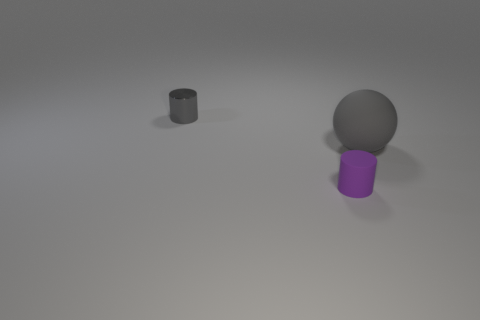What is the shape of the tiny thing that is in front of the big gray matte object?
Your answer should be compact. Cylinder. What number of other objects are there of the same material as the ball?
Offer a very short reply. 1. Is the sphere the same color as the small metallic cylinder?
Your answer should be very brief. Yes. Are there fewer gray rubber balls behind the metallic object than big gray matte balls in front of the big thing?
Your answer should be very brief. No. What is the color of the matte object that is the same shape as the shiny thing?
Provide a succinct answer. Purple. Does the cylinder that is in front of the ball have the same size as the big ball?
Provide a short and direct response. No. Are there fewer big gray objects left of the purple rubber thing than big red objects?
Keep it short and to the point. No. Is there any other thing that is the same size as the gray shiny thing?
Offer a very short reply. Yes. There is a cylinder in front of the big thing in front of the tiny gray cylinder; what size is it?
Offer a very short reply. Small. Is there any other thing that is the same shape as the big thing?
Your answer should be compact. No. 